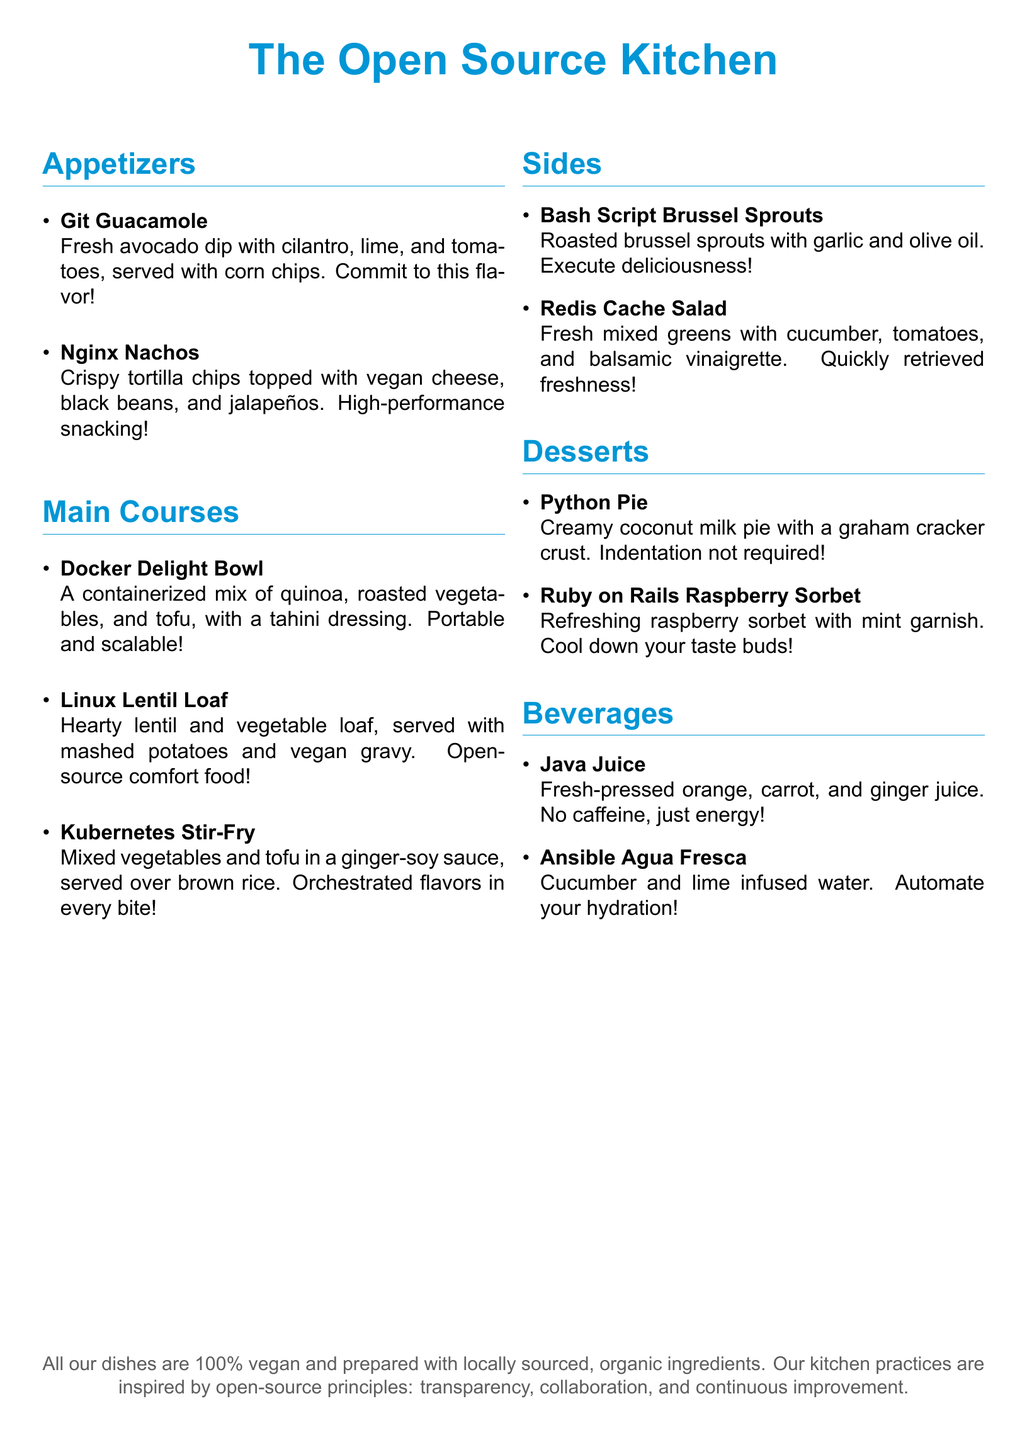What is the name of the appetizer that includes avocado? The appetizer featuring avocado is the Git Guacamole, which is described in the menu.
Answer: Git Guacamole How many main course items are listed? The document lists three main course items under the Main Courses section.
Answer: 3 What type of salad is mentioned as a side dish? The side dish mentioned is the Redis Cache Salad, which includes mixed greens and other ingredients.
Answer: Redis Cache Salad Which dessert includes raspberry? The dessert that features raspberry is the Ruby on Rails Raspberry Sorbet.
Answer: Ruby on Rails Raspberry Sorbet What is the main ingredient in the Docker Delight Bowl? The Docker Delight Bowl primarily consists of quinoa, as indicated in its description.
Answer: Quinoa How many beverages are listed on the menu? There are two beverage options mentioned in the Beverages section of the document.
Answer: 2 What is the color of the document's title? The color of the title, The Open Source Kitchen, is described as nginx blue in the document.
Answer: nginx blue Which main course is described as comfort food? The dish referred to as comfort food is the Linux Lentil Loaf, according to the menu description.
Answer: Linux Lentil Loaf What is the final note about the food practice? The final note states that all dishes are 100% vegan and prepared with locally sourced, organic ingredients.
Answer: 100% vegan 